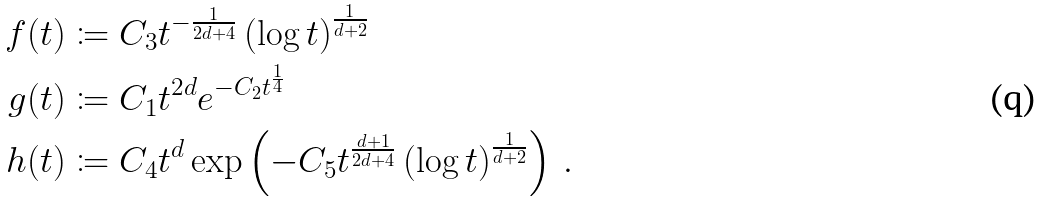Convert formula to latex. <formula><loc_0><loc_0><loc_500><loc_500>f ( t ) & \coloneqq C _ { 3 } t ^ { - \frac { 1 } { 2 d + 4 } } \left ( \log t \right ) ^ { \frac { 1 } { d + 2 } } \\ g ( t ) & \coloneqq C _ { 1 } t ^ { 2 d } e ^ { - C _ { 2 } t ^ { \frac { 1 } { 4 } } } \\ h ( t ) & \coloneqq C _ { 4 } t ^ { d } \exp \left ( - C _ { 5 } t ^ { \frac { d + 1 } { 2 d + 4 } } \left ( \log t \right ) ^ { \frac { 1 } { d + 2 } } \right ) \, .</formula> 